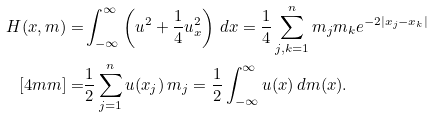<formula> <loc_0><loc_0><loc_500><loc_500>H ( x , m ) = & \int ^ { \infty } _ { - \infty } \left ( u ^ { 2 } + \frac { 1 } { 4 } u _ { x } ^ { 2 } \right ) \, d x = \frac { 1 } { 4 } \sum ^ { n } _ { j , k = 1 } m _ { j } m _ { k } e ^ { - 2 | x _ { j } - x _ { k } | } \\ [ 4 m m ] = & \frac { 1 } { 2 } \sum ^ { n } _ { j = 1 } u ( x _ { j } ) \, m _ { j } = \frac { 1 } { 2 } \int _ { - \infty } ^ { \infty } u ( x ) \, d m ( x ) .</formula> 